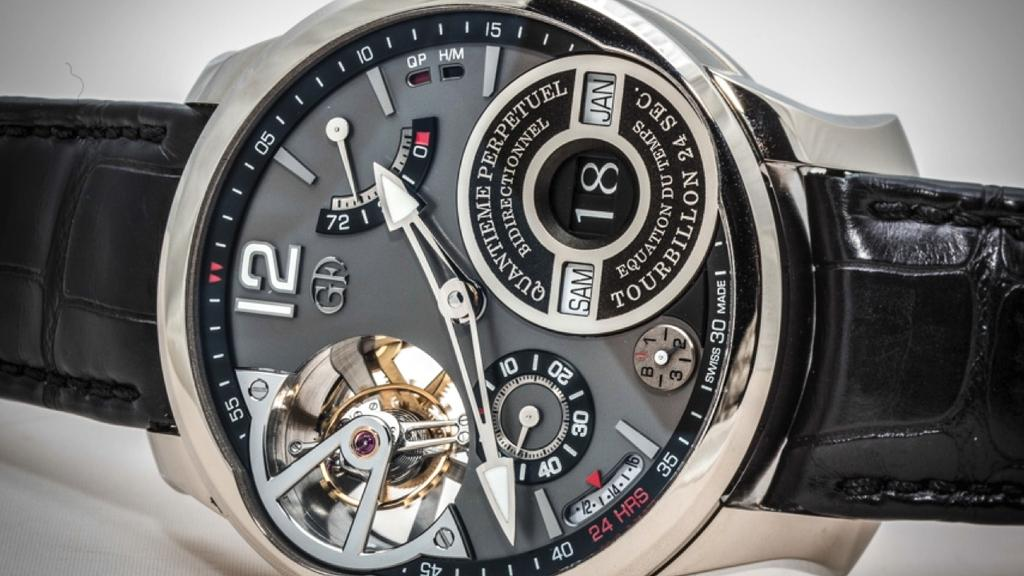<image>
Describe the image concisely. A fancy GP Quantieme Perpetual mechanical watch with a black face, silver bezel and black leather band. 